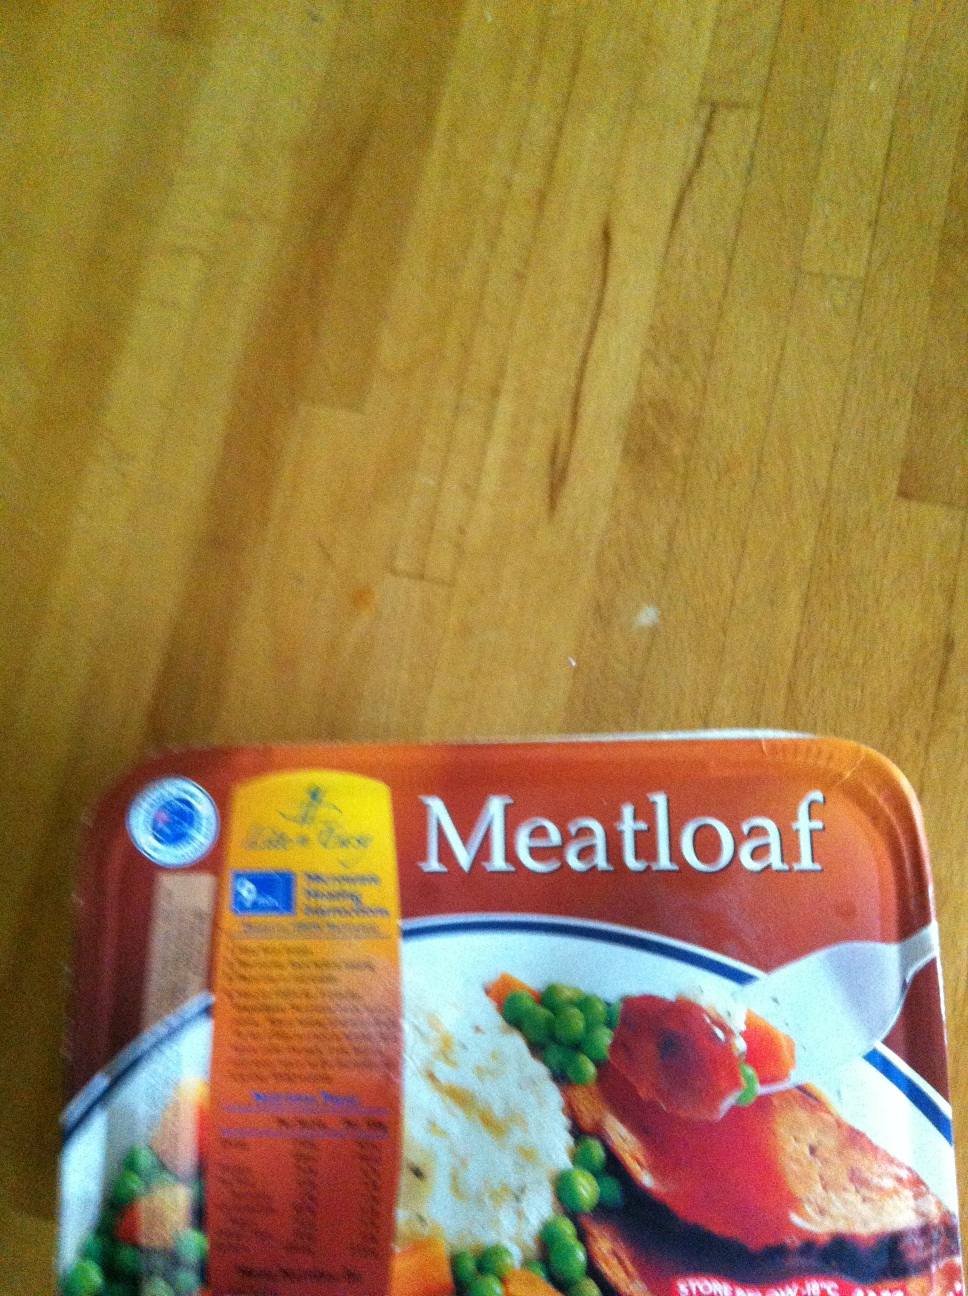If you were to write a short story about this meatloaf, what would it be? Once upon a time in a small cozy kitchen, there lived a meatloaf with a secret recipe passed down through generations. This wasn’t just any ordinary meatloaf; it was a blend of tender meats, seasoned with a melody of spices, and baked to perfection with a golden glaze. The meatloaf dreamed of finding a home where it could be enjoyed by a loving family. One day, it was bought by a kind-hearted chef who recognized the magic within. The chef prepared a grand feast, serving the meatloaf with the finest sides and sharing its heartwarming taste with everyone in the neighborhood. This meatloaf, now a legendary dish, brought joy and comfort, creating memories that would last forever. 